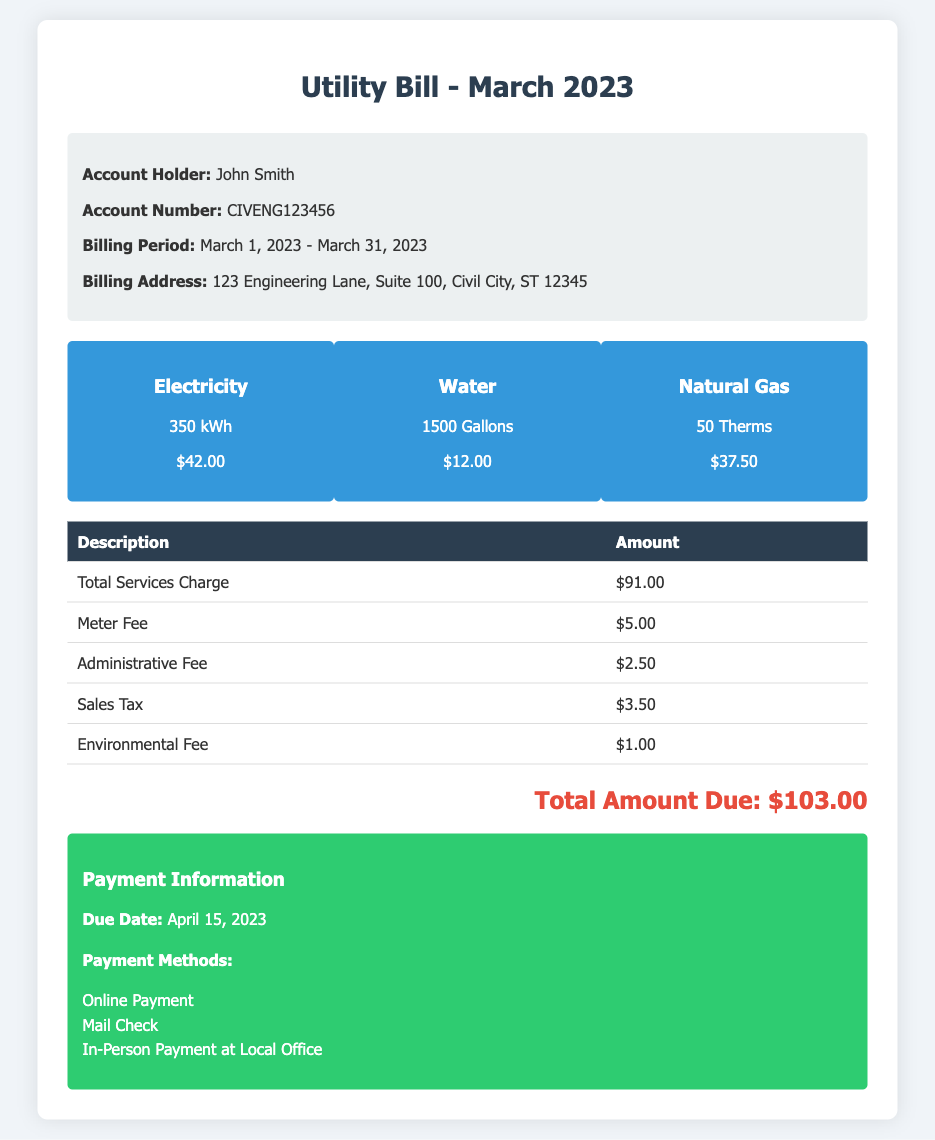What is the account holder's name? The document states that the account holder is John Smith.
Answer: John Smith How much was charged for electricity? The document indicates that electricity usage costs $42.00.
Answer: $42.00 What is the total number of gallons of water used? The document provides that the water usage is 1500 gallons.
Answer: 1500 Gallons What is the total amount due? The total amount due is clearly indicated as $103.00 in the document.
Answer: $103.00 What is the due date for payment? The document specifies that the due date for payment is April 15, 2023.
Answer: April 15, 2023 How much was charged for the meter fee? The document states that the meter fee is $5.00.
Answer: $5.00 What is the total service charge amount? The total services charge listed in the document is $91.00.
Answer: $91.00 How many therms of natural gas were used? According to the document, the usage of natural gas is 50 therms.
Answer: 50 Therms What is the administrative fee? The document shows that the administrative fee is $2.50.
Answer: $2.50 